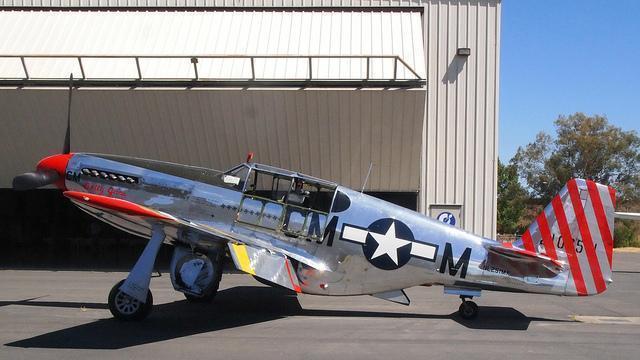How many toilet bowl brushes are in this picture?
Give a very brief answer. 0. 